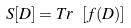<formula> <loc_0><loc_0><loc_500><loc_500>S [ D ] = T r \ [ f ( D ) ]</formula> 